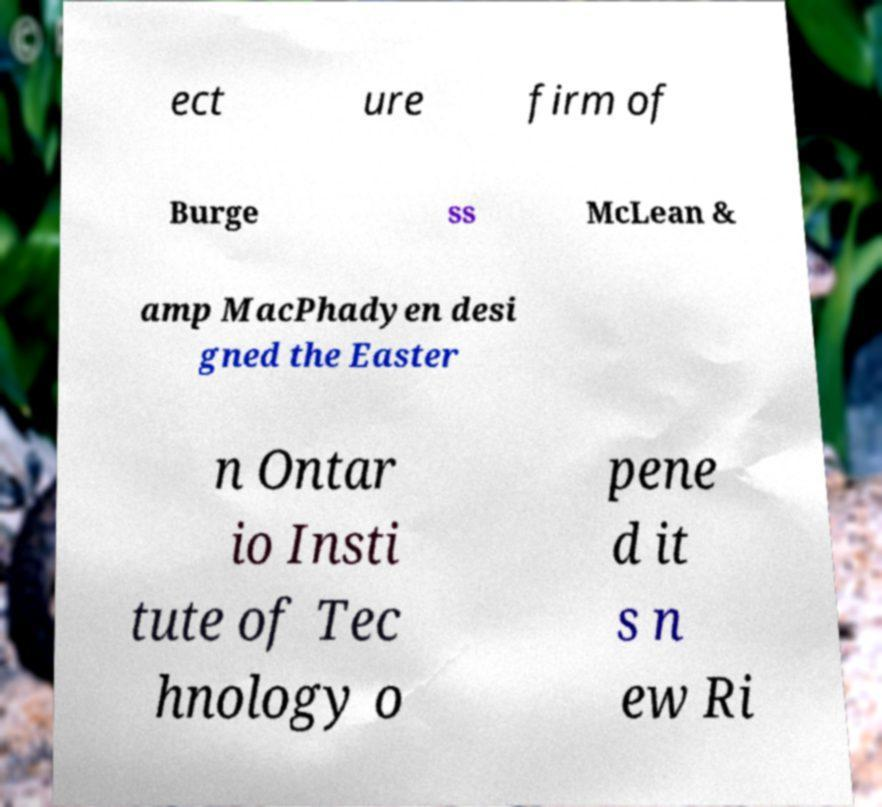Could you assist in decoding the text presented in this image and type it out clearly? ect ure firm of Burge ss McLean & amp MacPhadyen desi gned the Easter n Ontar io Insti tute of Tec hnology o pene d it s n ew Ri 